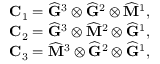Convert formula to latex. <formula><loc_0><loc_0><loc_500><loc_500>\begin{array} { r } { C _ { 1 } = \widehat { G } ^ { 3 } \otimes \widehat { G } ^ { 2 } \otimes \widehat { M } ^ { 1 } , } \\ { C _ { 2 } = \widehat { G } ^ { 3 } \otimes \widehat { M } ^ { 2 } \otimes \widehat { G } ^ { 1 } , } \\ { C _ { 3 } = \widehat { M } ^ { 3 } \otimes \widehat { G } ^ { 2 } \otimes \widehat { G } ^ { 1 } , } \end{array}</formula> 